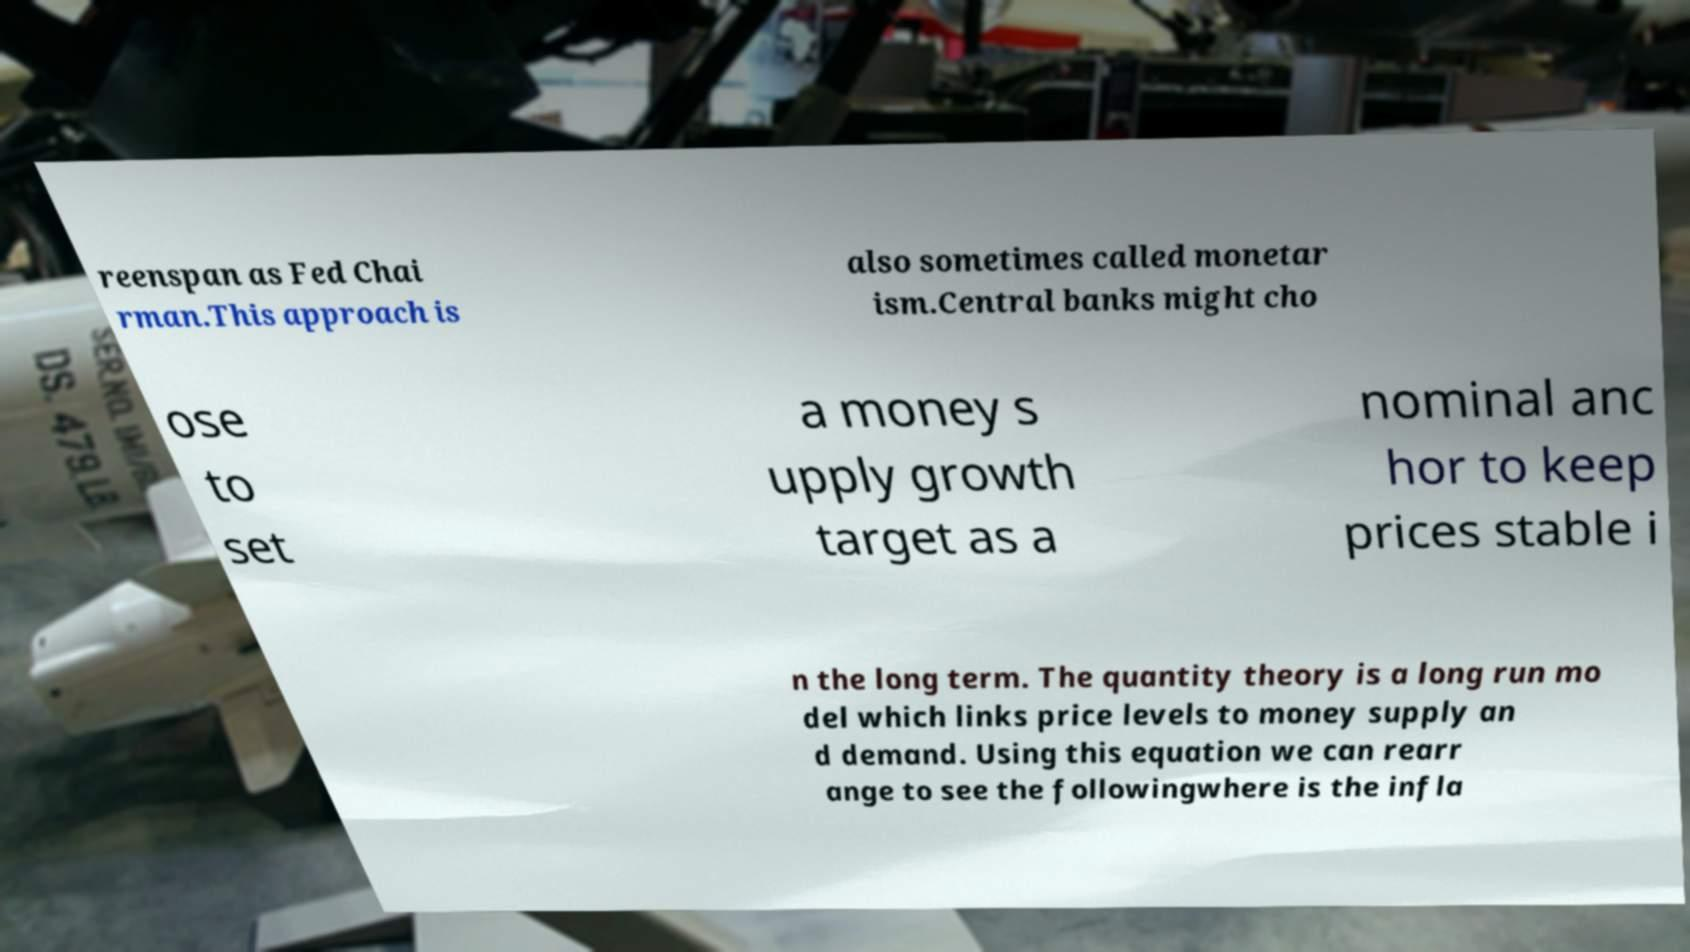Please identify and transcribe the text found in this image. reenspan as Fed Chai rman.This approach is also sometimes called monetar ism.Central banks might cho ose to set a money s upply growth target as a nominal anc hor to keep prices stable i n the long term. The quantity theory is a long run mo del which links price levels to money supply an d demand. Using this equation we can rearr ange to see the followingwhere is the infla 